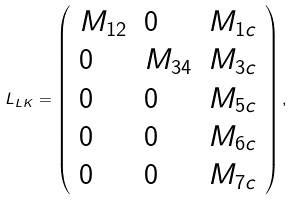Convert formula to latex. <formula><loc_0><loc_0><loc_500><loc_500>L _ { L K } = \left ( \begin{array} { l l l } M _ { 1 2 } & 0 & M _ { 1 c } \\ 0 & M _ { 3 4 } & M _ { 3 c } \\ 0 & 0 & M _ { 5 c } \\ 0 & 0 & M _ { 6 c } \\ 0 & 0 & M _ { 7 c } \end{array} \right ) ,</formula> 